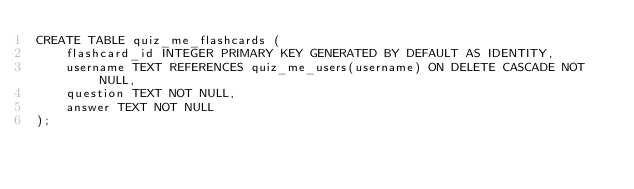Convert code to text. <code><loc_0><loc_0><loc_500><loc_500><_SQL_>CREATE TABLE quiz_me_flashcards (
    flashcard_id INTEGER PRIMARY KEY GENERATED BY DEFAULT AS IDENTITY,
    username TEXT REFERENCES quiz_me_users(username) ON DELETE CASCADE NOT NULL,
    question TEXT NOT NULL,
    answer TEXT NOT NULL
);</code> 